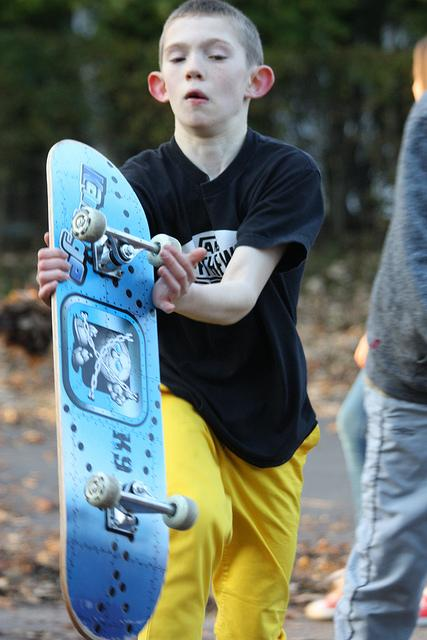What jungle animal do his ears resemble?

Choices:
A) tiger
B) snake
C) monkey
D) parrot monkey 